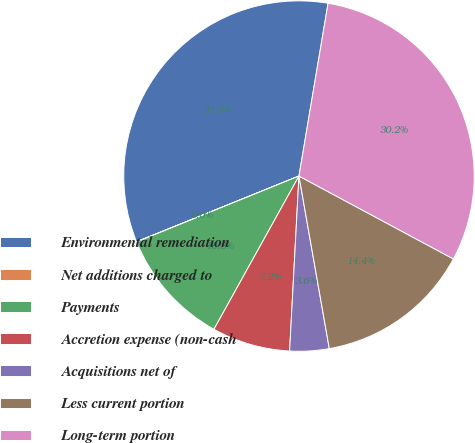Convert chart. <chart><loc_0><loc_0><loc_500><loc_500><pie_chart><fcel>Environmental remediation<fcel>Net additions charged to<fcel>Payments<fcel>Accretion expense (non-cash<fcel>Acquisitions net of<fcel>Less current portion<fcel>Long-term portion<nl><fcel>33.77%<fcel>0.02%<fcel>10.8%<fcel>7.21%<fcel>3.62%<fcel>14.39%<fcel>30.18%<nl></chart> 